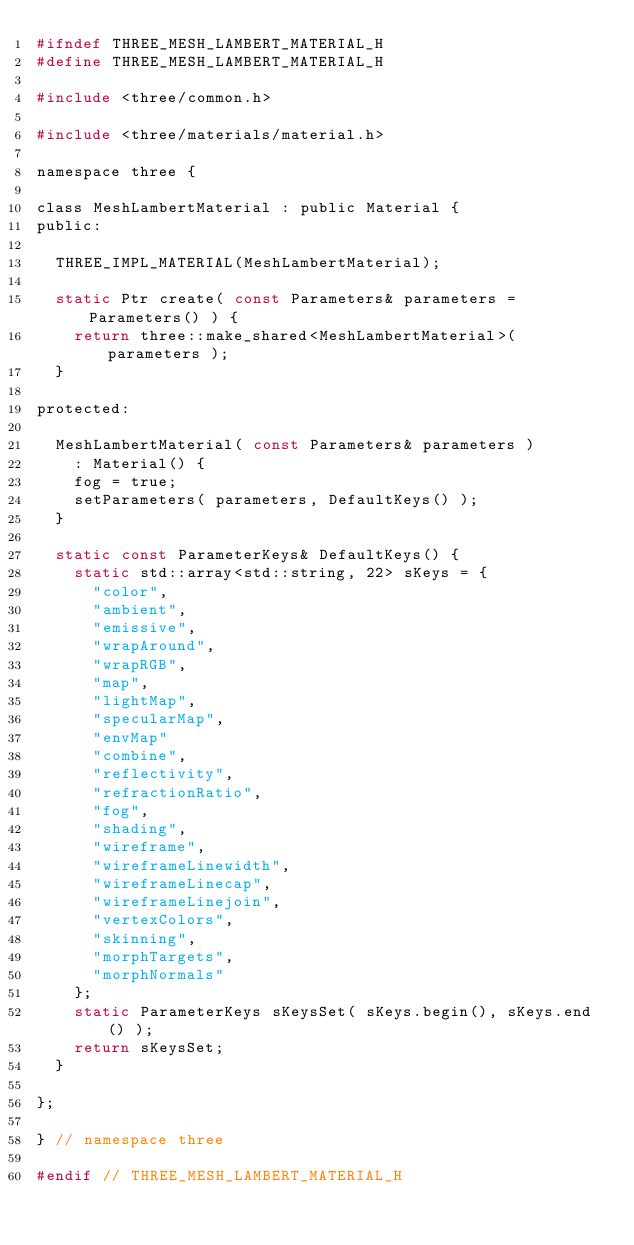<code> <loc_0><loc_0><loc_500><loc_500><_C_>#ifndef THREE_MESH_LAMBERT_MATERIAL_H
#define THREE_MESH_LAMBERT_MATERIAL_H

#include <three/common.h>

#include <three/materials/material.h>

namespace three {

class MeshLambertMaterial : public Material {
public:

  THREE_IMPL_MATERIAL(MeshLambertMaterial);

  static Ptr create( const Parameters& parameters = Parameters() ) {
    return three::make_shared<MeshLambertMaterial>( parameters );
  }

protected:

  MeshLambertMaterial( const Parameters& parameters )
    : Material() {
    fog = true;
    setParameters( parameters, DefaultKeys() );
  }

  static const ParameterKeys& DefaultKeys() {
    static std::array<std::string, 22> sKeys = {
      "color",
      "ambient",
      "emissive",
      "wrapAround",
      "wrapRGB",
      "map",
      "lightMap",
      "specularMap",
      "envMap"
      "combine",
      "reflectivity",
      "refractionRatio",
      "fog",
      "shading",
      "wireframe",
      "wireframeLinewidth",
      "wireframeLinecap",
      "wireframeLinejoin",
      "vertexColors",
      "skinning",
      "morphTargets",
      "morphNormals"
    };
    static ParameterKeys sKeysSet( sKeys.begin(), sKeys.end() );
    return sKeysSet;
  }

};

} // namespace three

#endif // THREE_MESH_LAMBERT_MATERIAL_H

</code> 